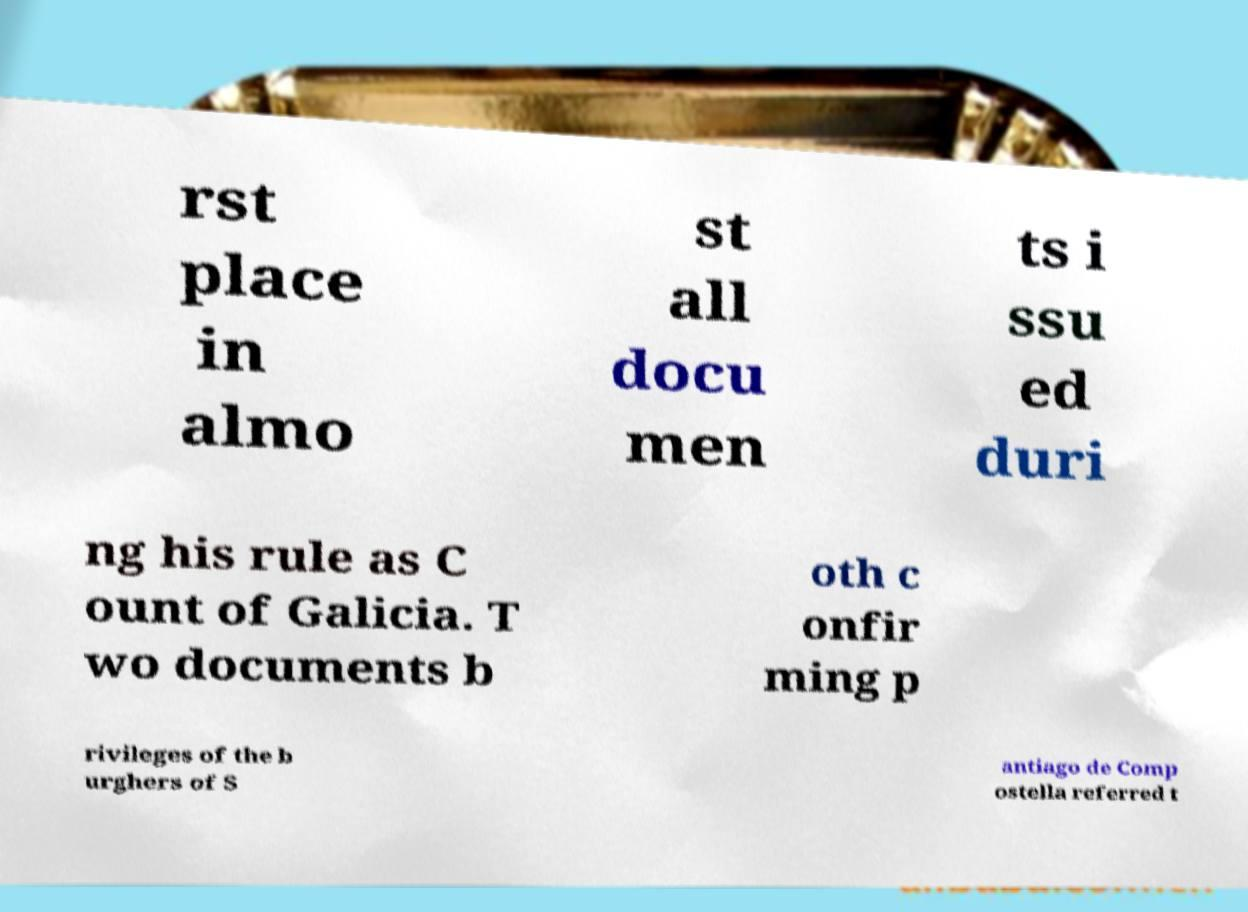For documentation purposes, I need the text within this image transcribed. Could you provide that? rst place in almo st all docu men ts i ssu ed duri ng his rule as C ount of Galicia. T wo documents b oth c onfir ming p rivileges of the b urghers of S antiago de Comp ostella referred t 